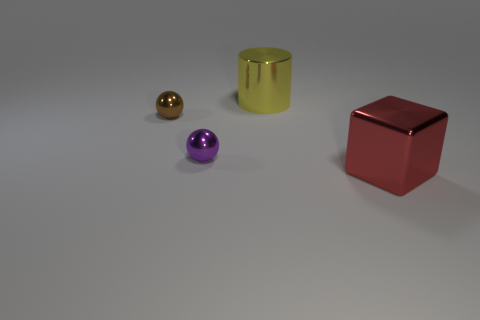Add 1 yellow rubber objects. How many objects exist? 5 Subtract all cubes. How many objects are left? 3 Subtract all large red things. Subtract all red cubes. How many objects are left? 2 Add 1 red shiny objects. How many red shiny objects are left? 2 Add 3 big red cubes. How many big red cubes exist? 4 Subtract 0 yellow cubes. How many objects are left? 4 